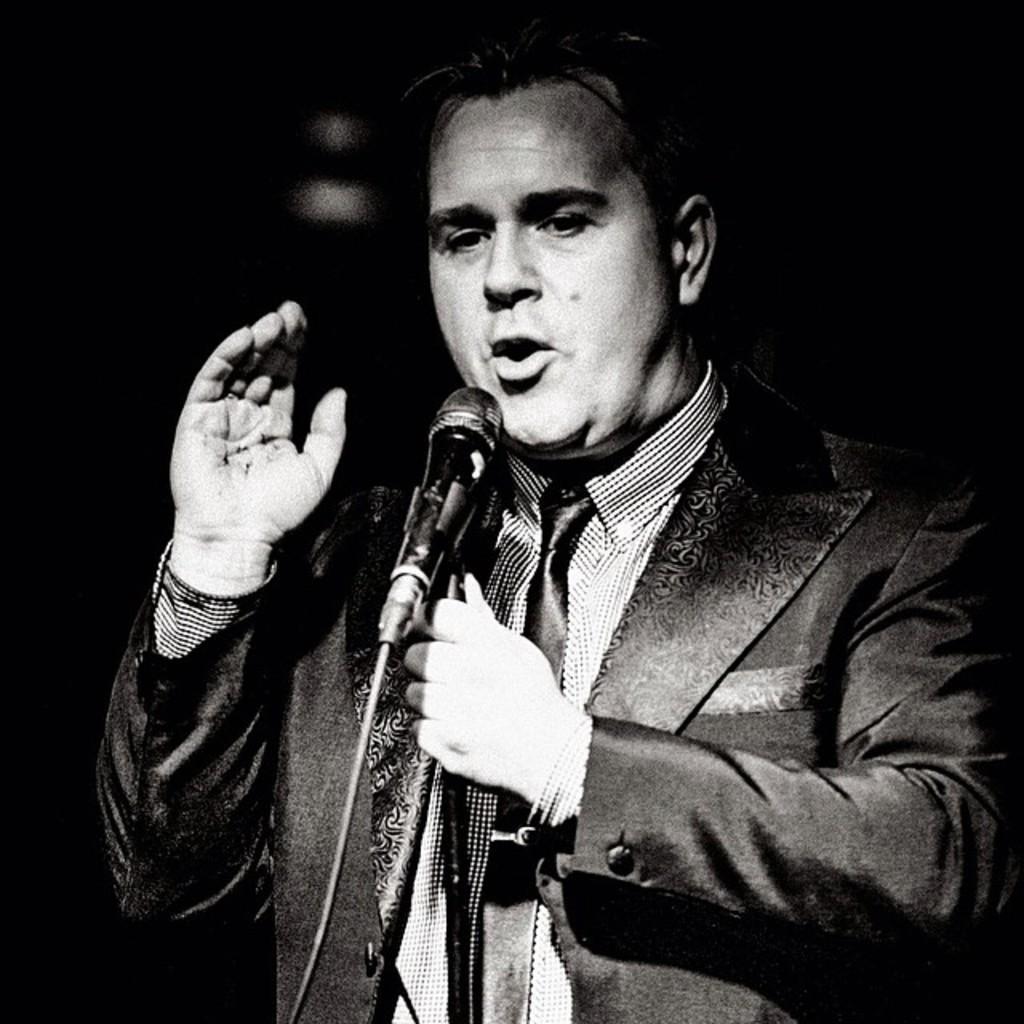Could you give a brief overview of what you see in this image? This is a black and white picture, a man in coat and shirt talking in the mic and the background is black. 